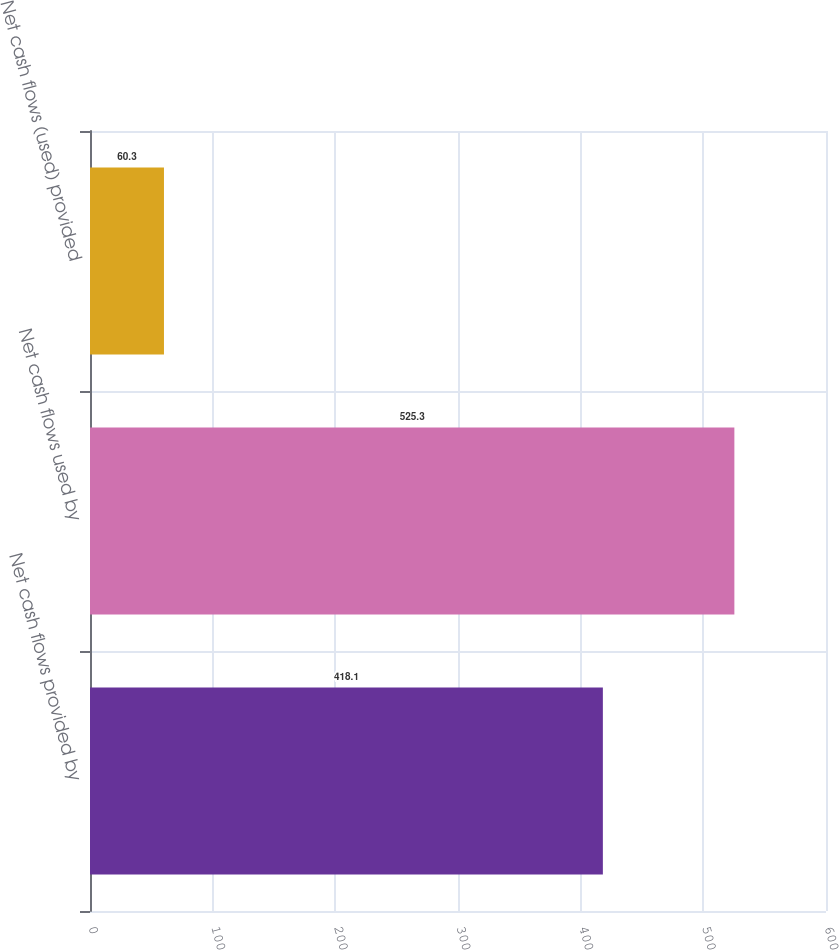Convert chart. <chart><loc_0><loc_0><loc_500><loc_500><bar_chart><fcel>Net cash flows provided by<fcel>Net cash flows used by<fcel>Net cash flows (used) provided<nl><fcel>418.1<fcel>525.3<fcel>60.3<nl></chart> 